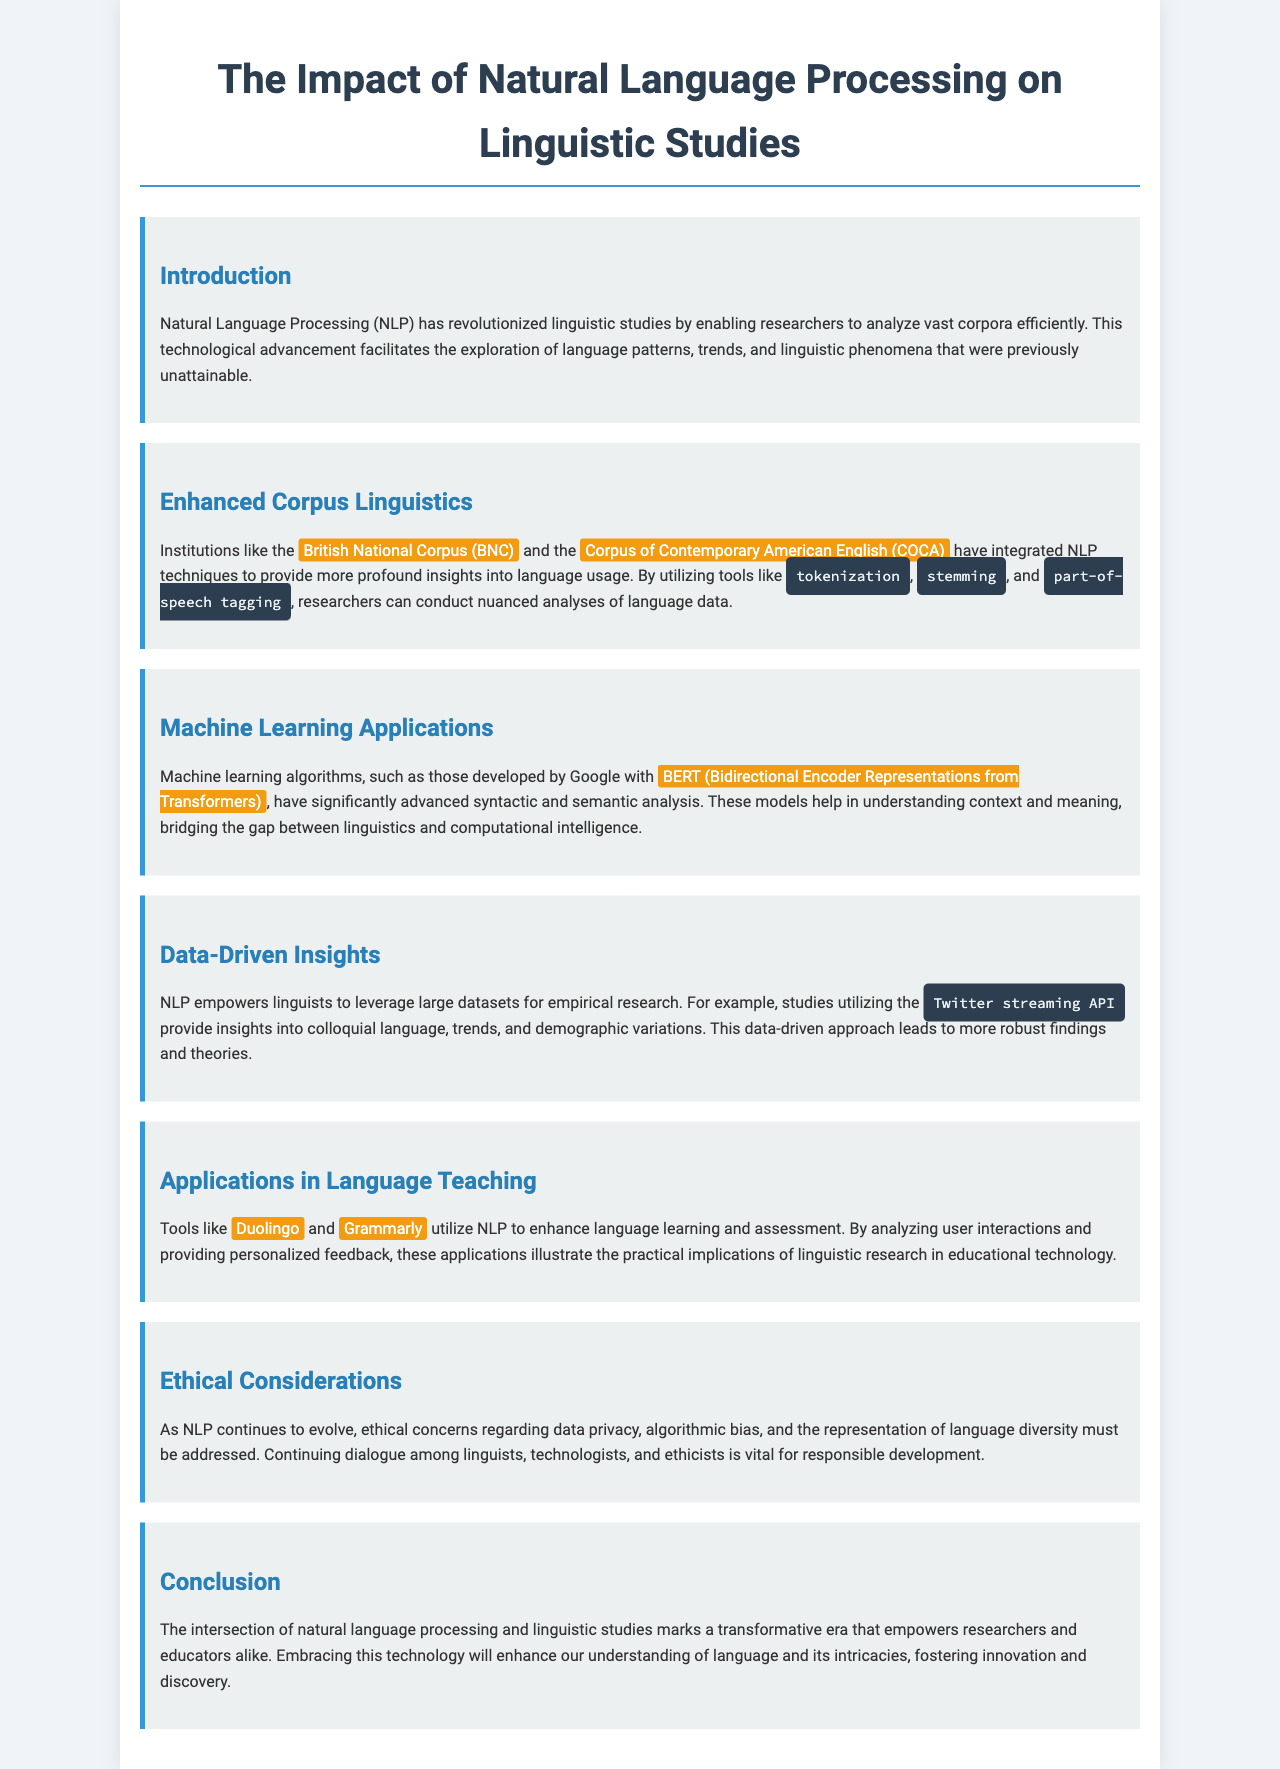what technological advancement enables efficient analysis of vast corpora? The document states that Natural Language Processing (NLP) has revolutionized linguistic studies by enabling researchers to analyze vast corpora efficiently.
Answer: Natural Language Processing which two corpora are integrated with NLP techniques? The document mentions the British National Corpus (BNC) and the Corpus of Contemporary American English (COCA) as examples of institutions that have integrated NLP techniques.
Answer: British National Corpus, Corpus of Contemporary American English what machine learning model developed by Google is mentioned in the document? The document specifically describes BERT (Bidirectional Encoder Representations from Transformers) as a significant machine learning model developed by Google.
Answer: BERT what data source is used for empirical research in the document? The document provides the example of the Twitter streaming API as a source for studies utilizing large datasets for empirical research.
Answer: Twitter streaming API what applications utilize NLP for language learning and assessment? The document lists Duolingo and Grammarly as tools that utilize NLP to enhance language learning and assessment.
Answer: Duolingo, Grammarly which ethical considerations are mentioned regarding the evolution of NLP? The ethical considerations highlighted in the document include data privacy, algorithmic bias, and the representation of language diversity.
Answer: Data privacy, algorithmic bias, language diversity what is the primary focus of this brochure? The brochure discusses the transformative impact of Natural Language Processing on linguistic studies and the implications for researchers and educators.
Answer: Impact of Natural Language Processing on linguistic studies how does NLP empower linguists in research according to the document? The document states that NLP empowers linguists to leverage large datasets for empirical research leading to more robust findings and theories.
Answer: Leverage large datasets for empirical research 